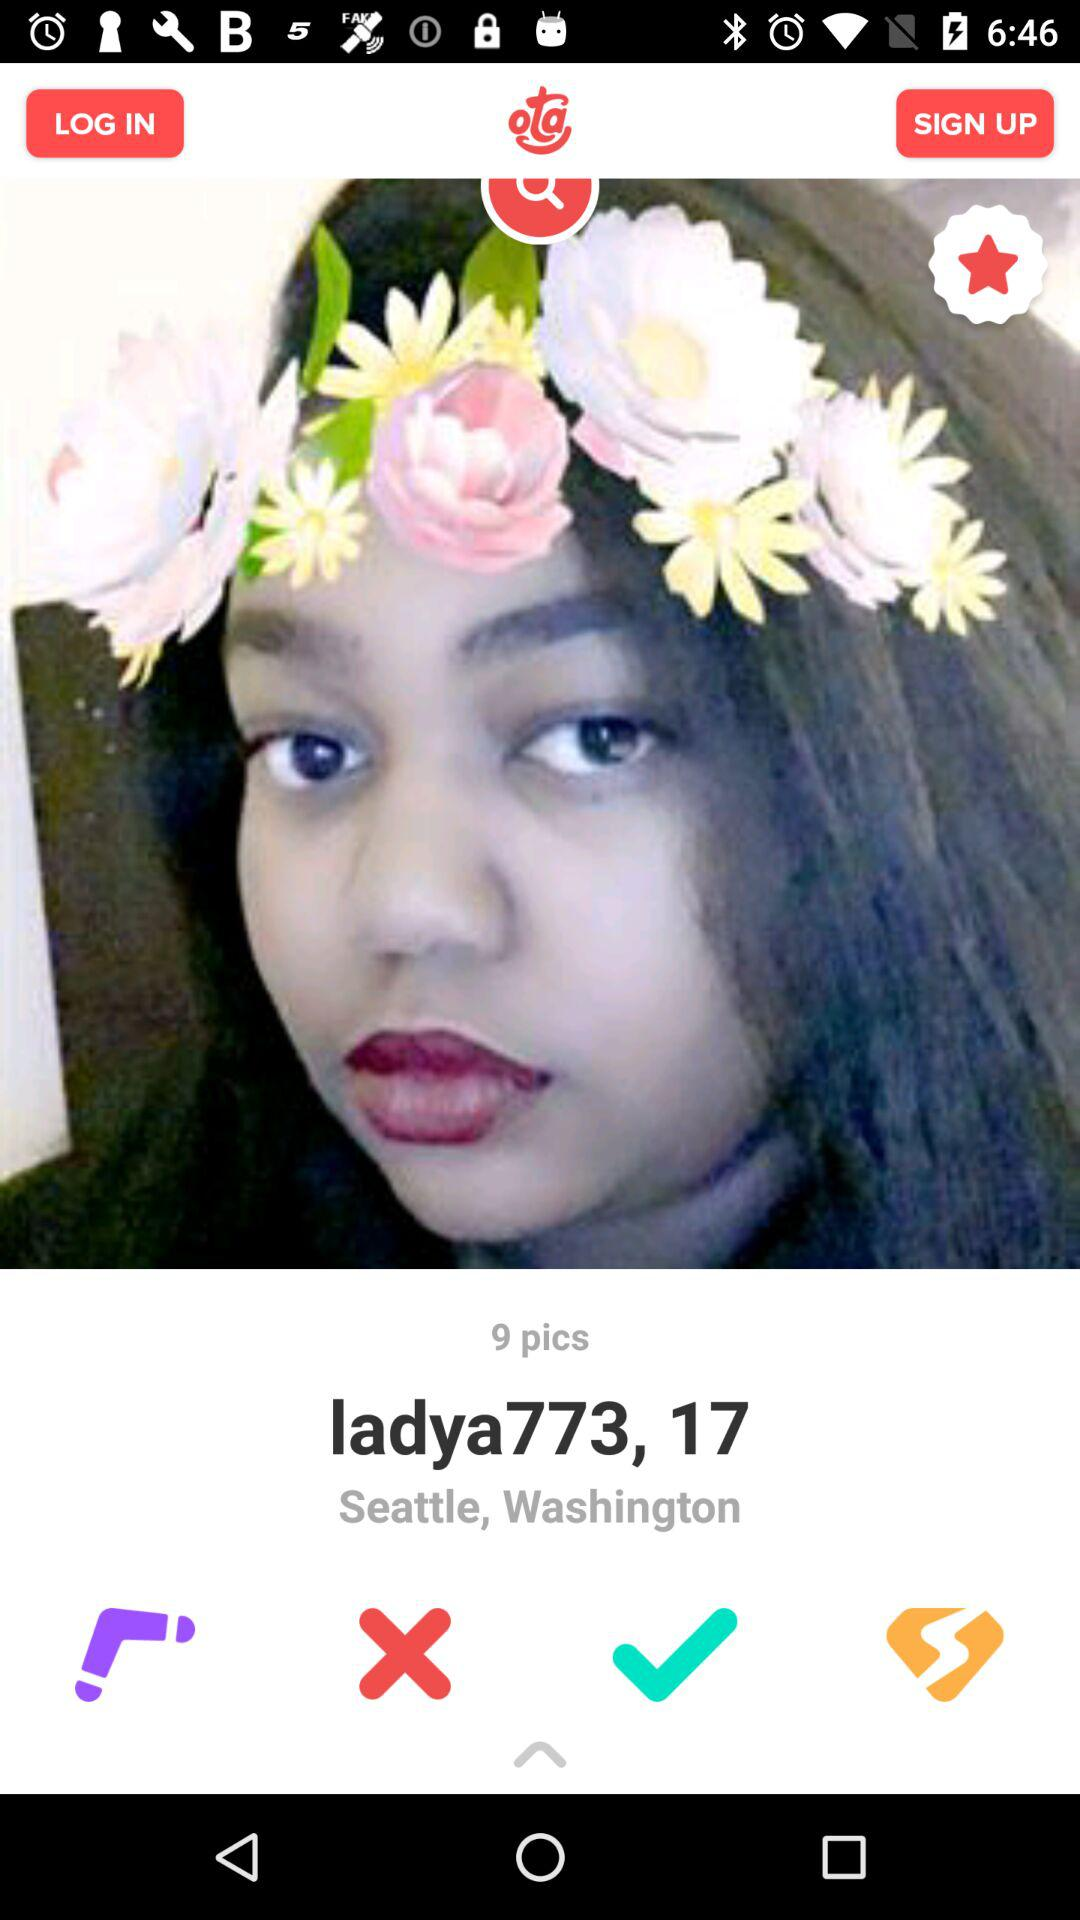How many pictures does the user have?
Answer the question using a single word or phrase. 9 